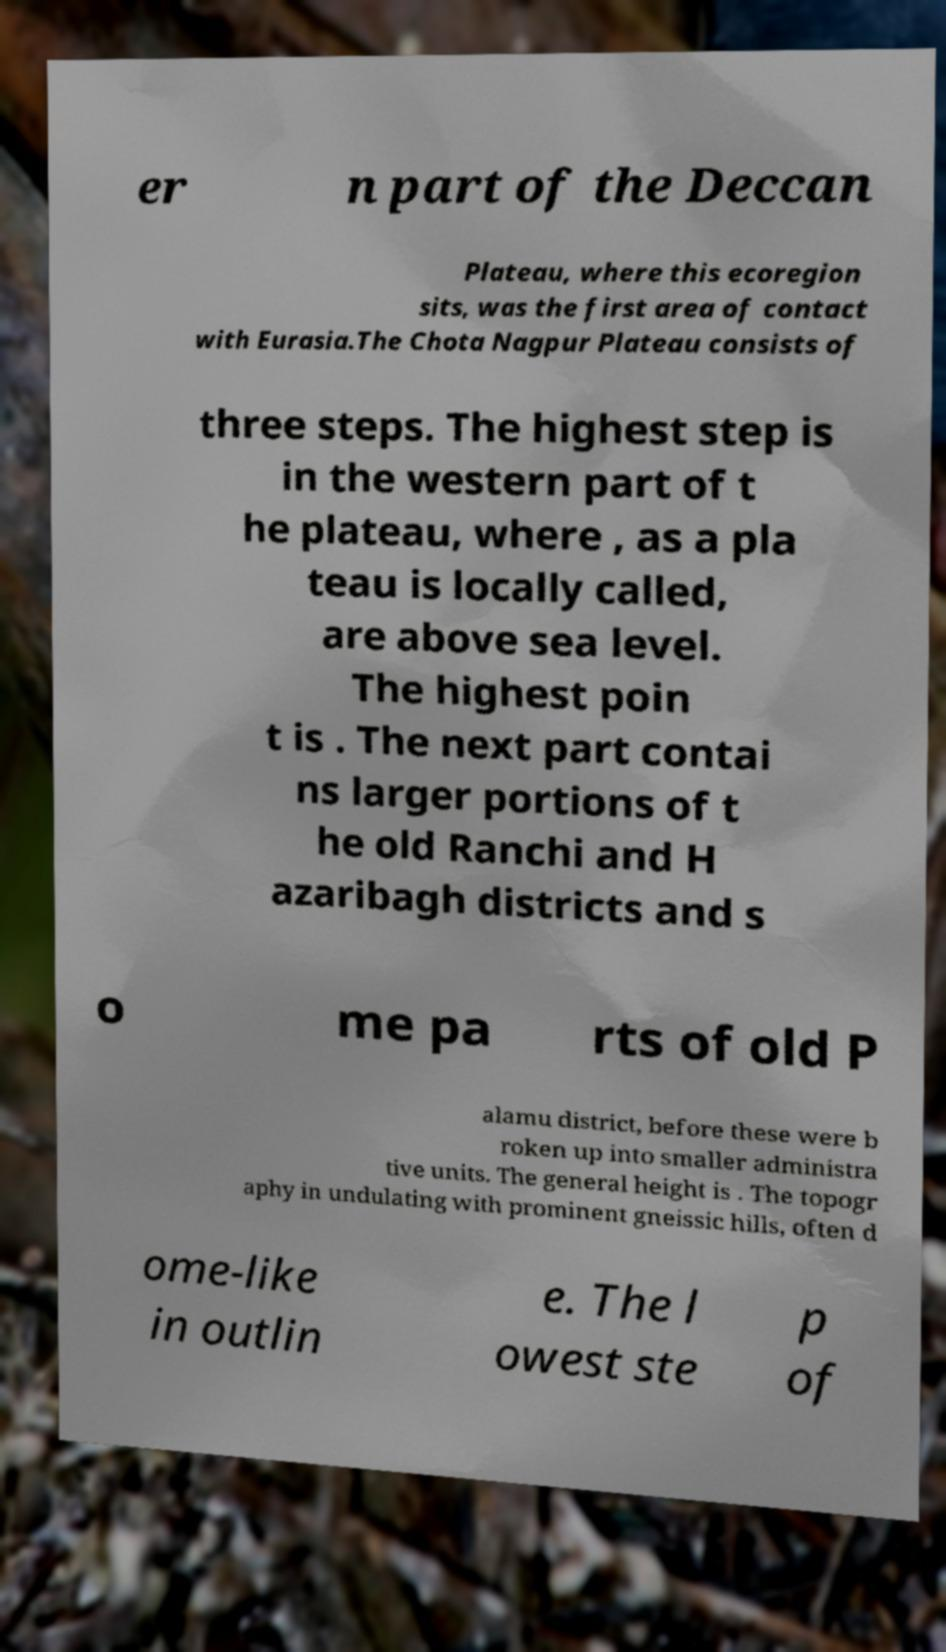I need the written content from this picture converted into text. Can you do that? er n part of the Deccan Plateau, where this ecoregion sits, was the first area of contact with Eurasia.The Chota Nagpur Plateau consists of three steps. The highest step is in the western part of t he plateau, where , as a pla teau is locally called, are above sea level. The highest poin t is . The next part contai ns larger portions of t he old Ranchi and H azaribagh districts and s o me pa rts of old P alamu district, before these were b roken up into smaller administra tive units. The general height is . The topogr aphy in undulating with prominent gneissic hills, often d ome-like in outlin e. The l owest ste p of 